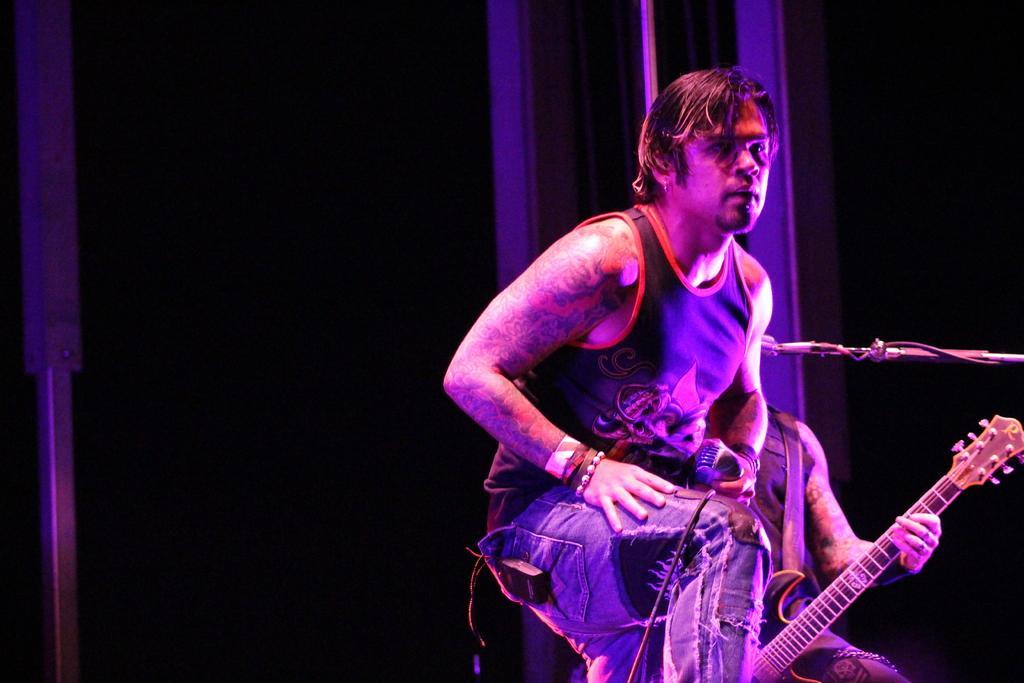How would you summarize this image in a sentence or two? In this image, there is a person holding wearing clothes and holding a mic with his hand. There is an another person playing a guitar in front of this mic. 